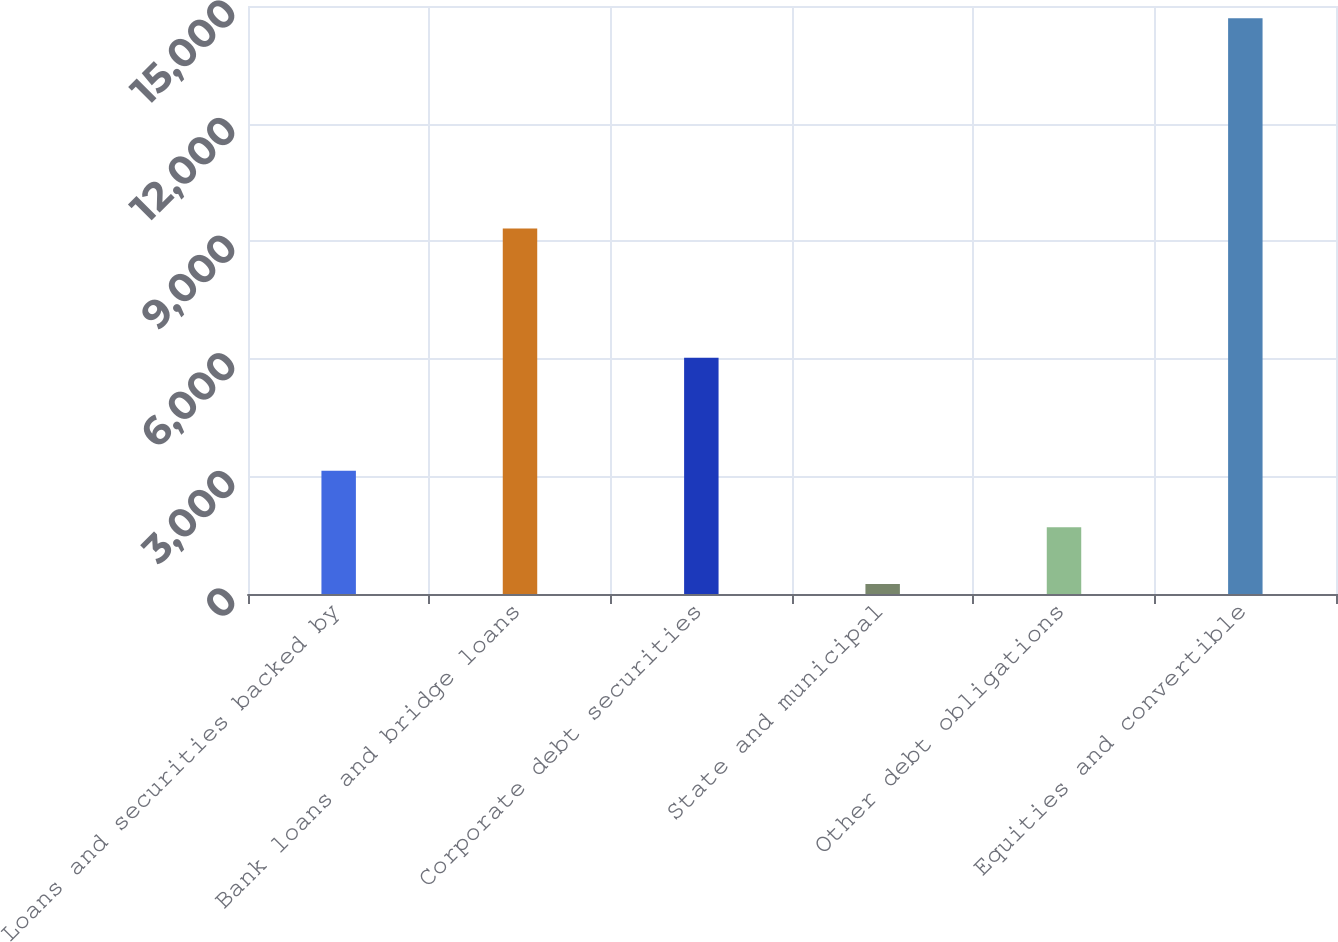<chart> <loc_0><loc_0><loc_500><loc_500><bar_chart><fcel>Loans and securities backed by<fcel>Bank loans and bridge loans<fcel>Corporate debt securities<fcel>State and municipal<fcel>Other debt obligations<fcel>Equities and convertible<nl><fcel>3142.6<fcel>9324<fcel>6028.2<fcel>257<fcel>1699.8<fcel>14685<nl></chart> 